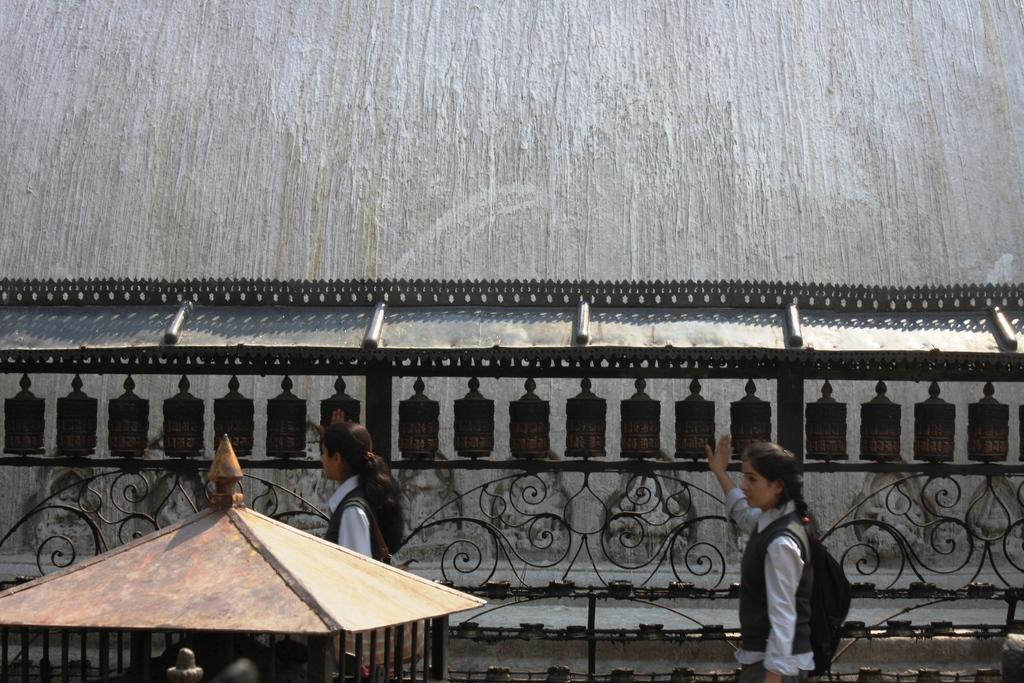How many people are in the image? There are two girls in the image. What is behind the girls in the image? There is a railing behind the girls. What can be seen in the background of the image? There is a wall in the background of the image. What is located in the bottom left corner of the image? There is a small tent in the bottom left corner of the image. What type of pest can be seen crawling on the girls in the image? There are no pests visible on the girls in the image. What kind of dirt is present on the ground in the image? There is no dirt visible on the ground in the image. 